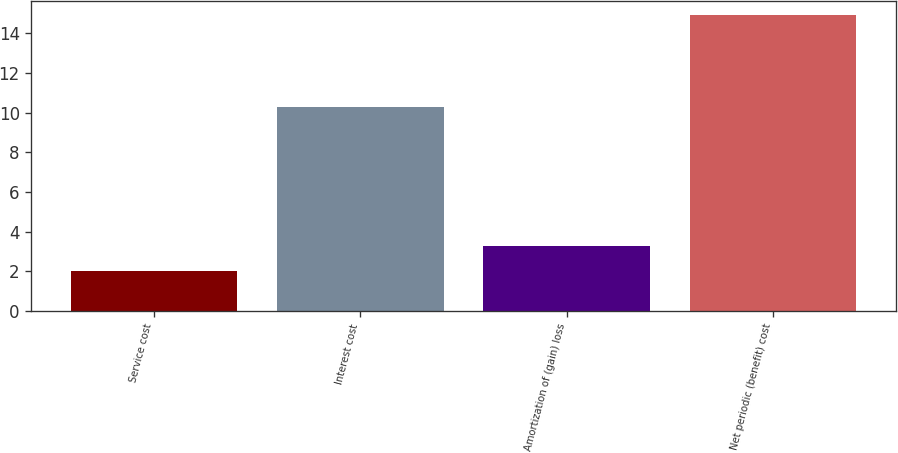<chart> <loc_0><loc_0><loc_500><loc_500><bar_chart><fcel>Service cost<fcel>Interest cost<fcel>Amortization of (gain) loss<fcel>Net periodic (benefit) cost<nl><fcel>2<fcel>10.3<fcel>3.29<fcel>14.9<nl></chart> 